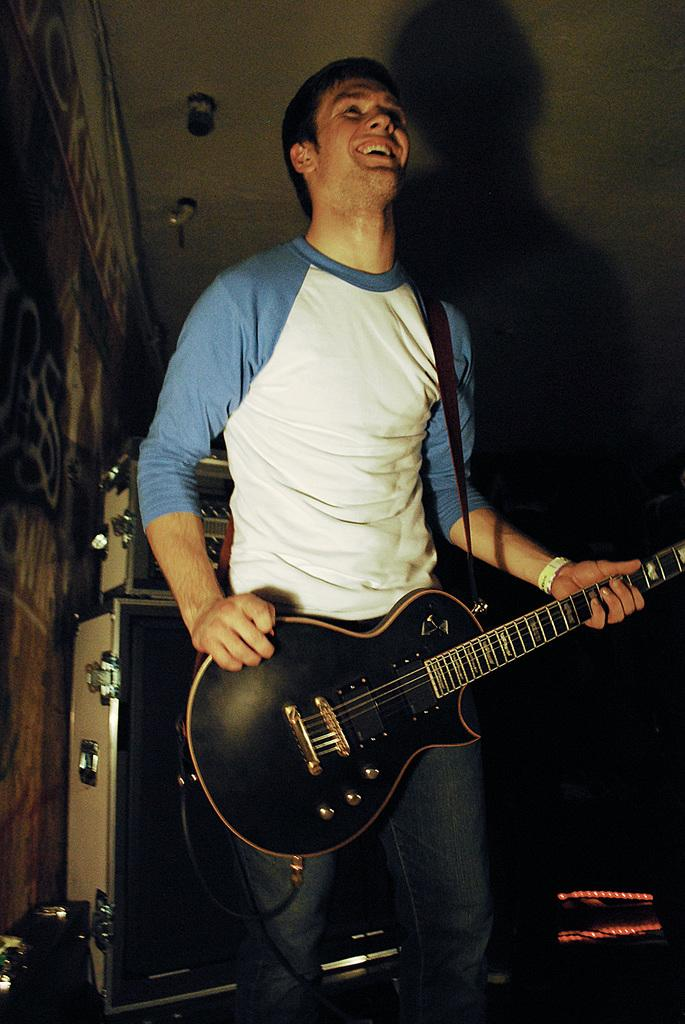What is the main subject of the image? There is a person in the image. What is the person wearing? The person is wearing a blue and white color T-shirt. What is the person doing in the image? The person is playing a musical instrument. What can be seen in the background of the image? There is a soundbox in the background of the image. How many crayons are visible in the image? There are no crayons present in the image. What type of border surrounds the person in the image? There is no border surrounding the person in the image. 